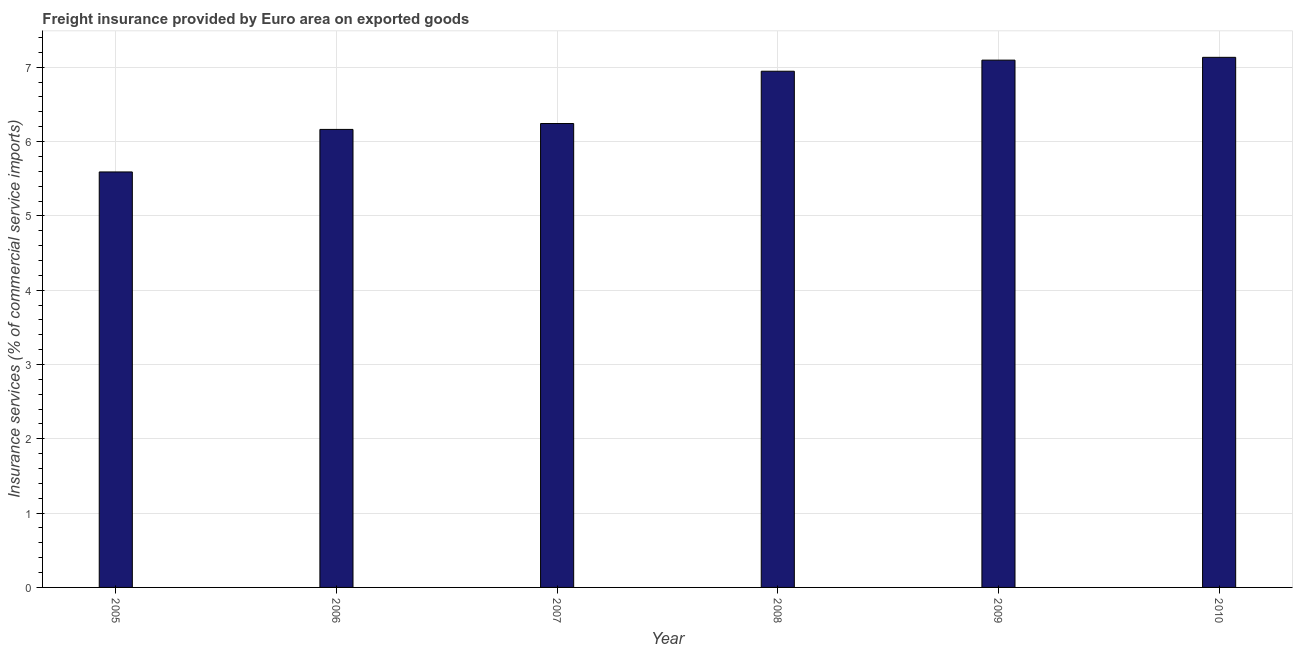Does the graph contain grids?
Give a very brief answer. Yes. What is the title of the graph?
Offer a very short reply. Freight insurance provided by Euro area on exported goods . What is the label or title of the X-axis?
Ensure brevity in your answer.  Year. What is the label or title of the Y-axis?
Keep it short and to the point. Insurance services (% of commercial service imports). What is the freight insurance in 2007?
Ensure brevity in your answer.  6.24. Across all years, what is the maximum freight insurance?
Provide a short and direct response. 7.13. Across all years, what is the minimum freight insurance?
Offer a terse response. 5.59. In which year was the freight insurance maximum?
Your answer should be very brief. 2010. In which year was the freight insurance minimum?
Provide a short and direct response. 2005. What is the sum of the freight insurance?
Your answer should be compact. 39.17. What is the difference between the freight insurance in 2006 and 2010?
Provide a succinct answer. -0.97. What is the average freight insurance per year?
Provide a succinct answer. 6.53. What is the median freight insurance?
Give a very brief answer. 6.59. In how many years, is the freight insurance greater than 3.8 %?
Offer a very short reply. 6. Do a majority of the years between 2009 and 2006 (inclusive) have freight insurance greater than 2 %?
Provide a short and direct response. Yes. What is the ratio of the freight insurance in 2005 to that in 2008?
Give a very brief answer. 0.81. What is the difference between the highest and the second highest freight insurance?
Your answer should be compact. 0.04. Is the sum of the freight insurance in 2005 and 2008 greater than the maximum freight insurance across all years?
Your response must be concise. Yes. What is the difference between the highest and the lowest freight insurance?
Offer a terse response. 1.54. How many bars are there?
Your answer should be compact. 6. How many years are there in the graph?
Your response must be concise. 6. Are the values on the major ticks of Y-axis written in scientific E-notation?
Provide a succinct answer. No. What is the Insurance services (% of commercial service imports) in 2005?
Make the answer very short. 5.59. What is the Insurance services (% of commercial service imports) of 2006?
Provide a short and direct response. 6.16. What is the Insurance services (% of commercial service imports) in 2007?
Offer a terse response. 6.24. What is the Insurance services (% of commercial service imports) in 2008?
Offer a terse response. 6.95. What is the Insurance services (% of commercial service imports) of 2009?
Your answer should be compact. 7.1. What is the Insurance services (% of commercial service imports) in 2010?
Provide a short and direct response. 7.13. What is the difference between the Insurance services (% of commercial service imports) in 2005 and 2006?
Give a very brief answer. -0.57. What is the difference between the Insurance services (% of commercial service imports) in 2005 and 2007?
Provide a succinct answer. -0.65. What is the difference between the Insurance services (% of commercial service imports) in 2005 and 2008?
Your answer should be compact. -1.36. What is the difference between the Insurance services (% of commercial service imports) in 2005 and 2009?
Your answer should be compact. -1.5. What is the difference between the Insurance services (% of commercial service imports) in 2005 and 2010?
Your answer should be very brief. -1.54. What is the difference between the Insurance services (% of commercial service imports) in 2006 and 2007?
Make the answer very short. -0.08. What is the difference between the Insurance services (% of commercial service imports) in 2006 and 2008?
Your answer should be compact. -0.78. What is the difference between the Insurance services (% of commercial service imports) in 2006 and 2009?
Make the answer very short. -0.93. What is the difference between the Insurance services (% of commercial service imports) in 2006 and 2010?
Make the answer very short. -0.97. What is the difference between the Insurance services (% of commercial service imports) in 2007 and 2008?
Give a very brief answer. -0.7. What is the difference between the Insurance services (% of commercial service imports) in 2007 and 2009?
Ensure brevity in your answer.  -0.85. What is the difference between the Insurance services (% of commercial service imports) in 2007 and 2010?
Make the answer very short. -0.89. What is the difference between the Insurance services (% of commercial service imports) in 2008 and 2009?
Offer a very short reply. -0.15. What is the difference between the Insurance services (% of commercial service imports) in 2008 and 2010?
Offer a very short reply. -0.19. What is the difference between the Insurance services (% of commercial service imports) in 2009 and 2010?
Keep it short and to the point. -0.04. What is the ratio of the Insurance services (% of commercial service imports) in 2005 to that in 2006?
Provide a succinct answer. 0.91. What is the ratio of the Insurance services (% of commercial service imports) in 2005 to that in 2007?
Your answer should be compact. 0.9. What is the ratio of the Insurance services (% of commercial service imports) in 2005 to that in 2008?
Offer a terse response. 0.81. What is the ratio of the Insurance services (% of commercial service imports) in 2005 to that in 2009?
Your answer should be compact. 0.79. What is the ratio of the Insurance services (% of commercial service imports) in 2005 to that in 2010?
Ensure brevity in your answer.  0.78. What is the ratio of the Insurance services (% of commercial service imports) in 2006 to that in 2007?
Provide a succinct answer. 0.99. What is the ratio of the Insurance services (% of commercial service imports) in 2006 to that in 2008?
Your response must be concise. 0.89. What is the ratio of the Insurance services (% of commercial service imports) in 2006 to that in 2009?
Your answer should be very brief. 0.87. What is the ratio of the Insurance services (% of commercial service imports) in 2006 to that in 2010?
Offer a very short reply. 0.86. What is the ratio of the Insurance services (% of commercial service imports) in 2007 to that in 2008?
Keep it short and to the point. 0.9. What is the ratio of the Insurance services (% of commercial service imports) in 2008 to that in 2009?
Give a very brief answer. 0.98. What is the ratio of the Insurance services (% of commercial service imports) in 2008 to that in 2010?
Provide a short and direct response. 0.97. What is the ratio of the Insurance services (% of commercial service imports) in 2009 to that in 2010?
Your answer should be very brief. 0.99. 